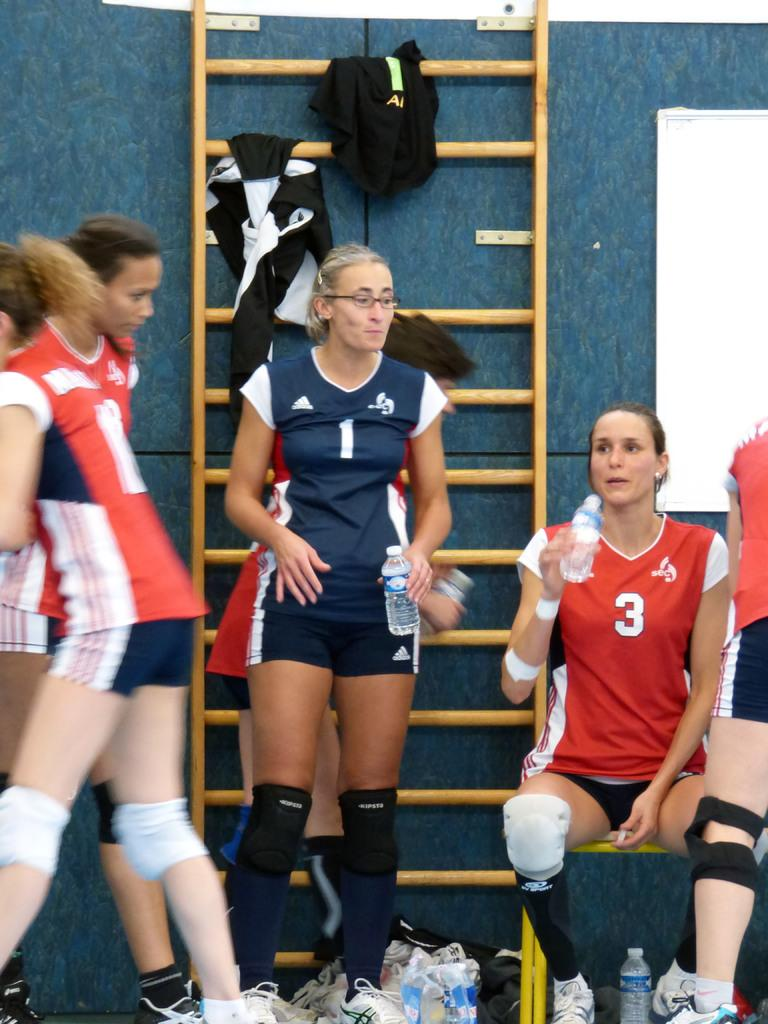<image>
Describe the image concisely. A woman in a number one basketball jersey. 